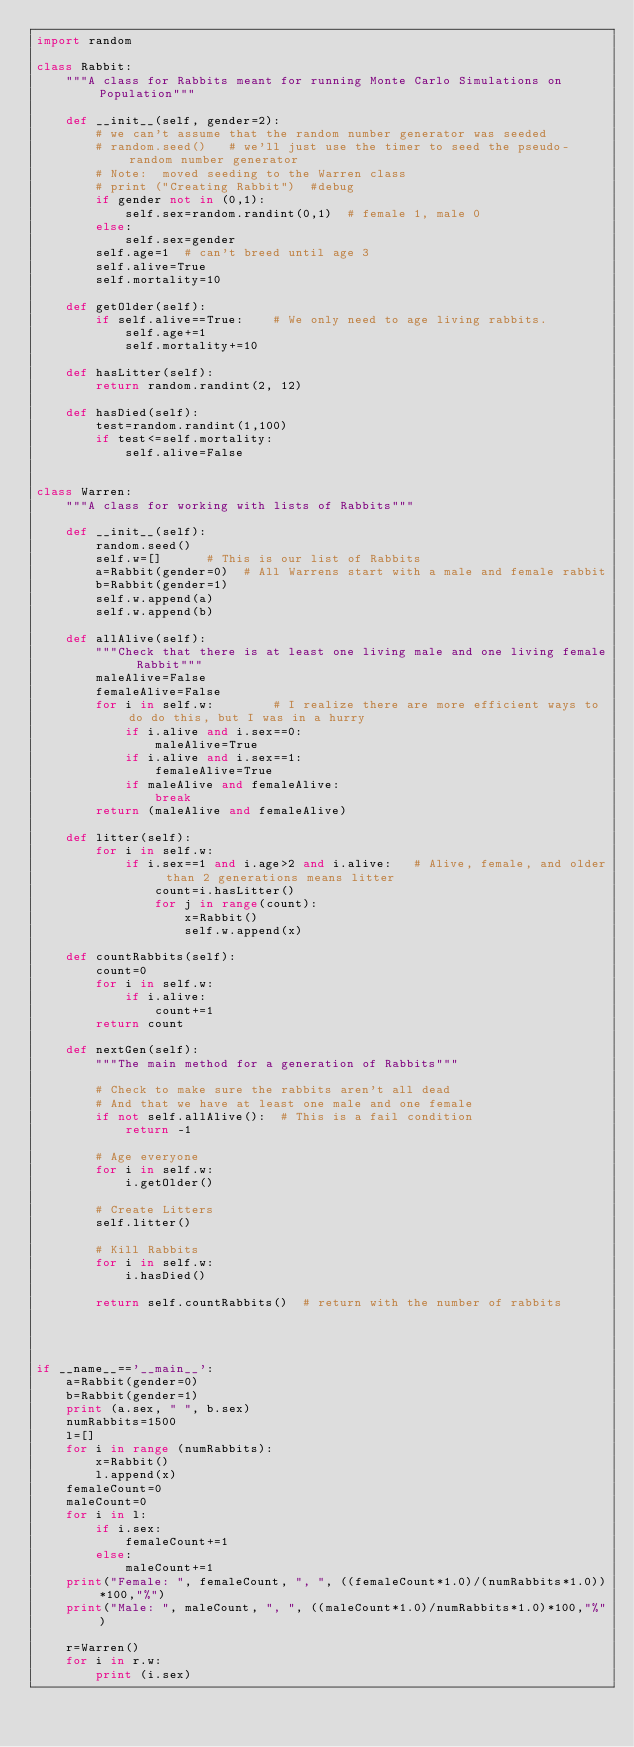<code> <loc_0><loc_0><loc_500><loc_500><_Python_>import random

class Rabbit:
    """A class for Rabbits meant for running Monte Carlo Simulations on Population"""

    def __init__(self, gender=2):
        # we can't assume that the random number generator was seeded
        # random.seed()   # we'll just use the timer to seed the pseudo-random number generator 
        # Note:  moved seeding to the Warren class
        # print ("Creating Rabbit")  #debug
        if gender not in (0,1):
            self.sex=random.randint(0,1)  # female 1, male 0
        else:
            self.sex=gender
        self.age=1  # can't breed until age 3
        self.alive=True
        self.mortality=10

    def getOlder(self):
        if self.alive==True:    # We only need to age living rabbits.  
            self.age+=1
            self.mortality+=10

    def hasLitter(self):
        return random.randint(2, 12) 

    def hasDied(self):
        test=random.randint(1,100)
        if test<=self.mortality:
            self.alive=False


class Warren:
    """A class for working with lists of Rabbits"""

    def __init__(self):
        random.seed()
        self.w=[]      # This is our list of Rabbits
        a=Rabbit(gender=0)  # All Warrens start with a male and female rabbit
        b=Rabbit(gender=1)
        self.w.append(a)
        self.w.append(b)

    def allAlive(self):
        """Check that there is at least one living male and one living female Rabbit"""
        maleAlive=False
        femaleAlive=False
        for i in self.w:        # I realize there are more efficient ways to do do this, but I was in a hurry
            if i.alive and i.sex==0:
                maleAlive=True
            if i.alive and i.sex==1:
                femaleAlive=True
            if maleAlive and femaleAlive:
                break
        return (maleAlive and femaleAlive)
        
    def litter(self):
        for i in self.w:
            if i.sex==1 and i.age>2 and i.alive:   # Alive, female, and older than 2 generations means litter
                count=i.hasLitter() 
                for j in range(count):
                    x=Rabbit()
                    self.w.append(x)
                    
    def countRabbits(self):
        count=0
        for i in self.w:
            if i.alive:
                count+=1
        return count

    def nextGen(self):
        """The main method for a generation of Rabbits"""
        
        # Check to make sure the rabbits aren't all dead
        # And that we have at least one male and one female
        if not self.allAlive():  # This is a fail condition
            return -1

        # Age everyone
        for i in self.w:
            i.getOlder()
            
        # Create Litters
        self.litter()
        
        # Kill Rabbits
        for i in self.w:
            i.hasDied()
            
        return self.countRabbits()  # return with the number of rabbits
            
        


if __name__=='__main__':
    a=Rabbit(gender=0)
    b=Rabbit(gender=1)
    print (a.sex, " ", b.sex)
    numRabbits=1500
    l=[]
    for i in range (numRabbits):
        x=Rabbit()
        l.append(x)
    femaleCount=0
    maleCount=0
    for i in l:
        if i.sex:
            femaleCount+=1
        else:
            maleCount+=1
    print("Female: ", femaleCount, ", ", ((femaleCount*1.0)/(numRabbits*1.0))*100,"%")
    print("Male: ", maleCount, ", ", ((maleCount*1.0)/numRabbits*1.0)*100,"%")

    r=Warren()
    for i in r.w:
        print (i.sex)</code> 